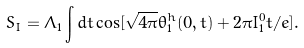<formula> <loc_0><loc_0><loc_500><loc_500>S _ { I } = \Lambda _ { 1 } \int d t \cos [ \sqrt { 4 \pi } \theta _ { 1 } ^ { h } ( 0 , t ) + 2 \pi I ^ { 0 } _ { 1 } t / e ] .</formula> 